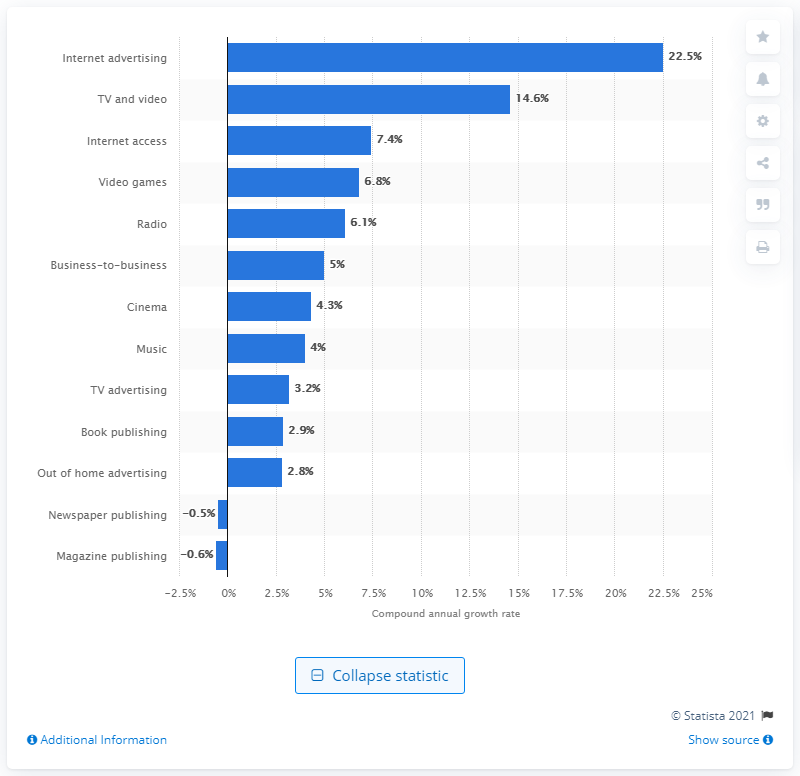Indicate a few pertinent items in this graphic. Radio advertising spending is expected to increase by 6.1% annually in the presented period. 